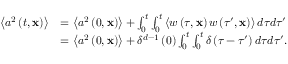Convert formula to latex. <formula><loc_0><loc_0><loc_500><loc_500>\begin{array} { r l } { \left \langle a ^ { 2 } \left ( t , x \right ) \right \rangle } & { = \left \langle a ^ { 2 } \left ( 0 , x \right ) \right \rangle + \int _ { 0 } ^ { t } \int _ { 0 } ^ { t } \left \langle w \left ( \tau , x \right ) w \left ( \tau ^ { \prime } , x \right ) \right \rangle d \tau d \tau ^ { \prime } } \\ & { = \left \langle a ^ { 2 } \left ( 0 , x \right ) \right \rangle + \delta ^ { d - 1 } \left ( 0 \right ) \int _ { 0 } ^ { t } \int _ { 0 } ^ { t } \delta \left ( \tau - \tau ^ { \prime } \right ) d \tau d \tau ^ { \prime } . } \end{array}</formula> 